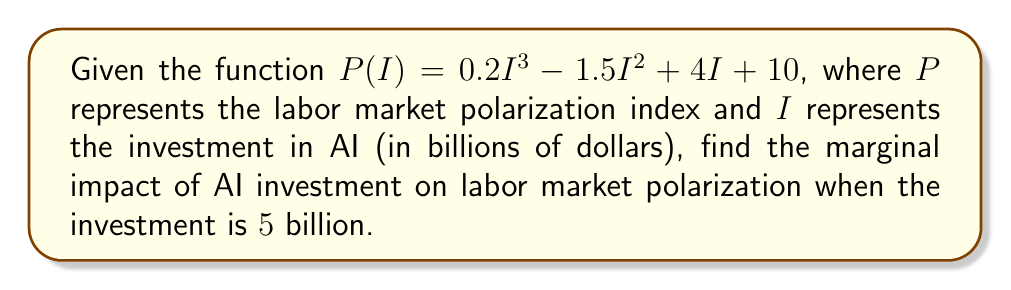Can you answer this question? To find the marginal impact of AI investment on labor market polarization, we need to calculate the derivative of the function $P(I)$ and then evaluate it at $I = 5$.

Step 1: Find the derivative of $P(I)$.
$$\frac{dP}{dI} = \frac{d}{dI}(0.2I^3 - 1.5I^2 + 4I + 10)$$
$$\frac{dP}{dI} = 0.6I^2 - 3I + 4$$

Step 2: Evaluate the derivative at $I = 5$.
$$\frac{dP}{dI}\bigg|_{I=5} = 0.6(5)^2 - 3(5) + 4$$
$$\frac{dP}{dI}\bigg|_{I=5} = 0.6(25) - 15 + 4$$
$$\frac{dP}{dI}\bigg|_{I=5} = 15 - 15 + 4 = 4$$

The marginal impact of AI investment on labor market polarization when the investment is $5 billion is 4 units per billion dollars invested.
Answer: $4$ 